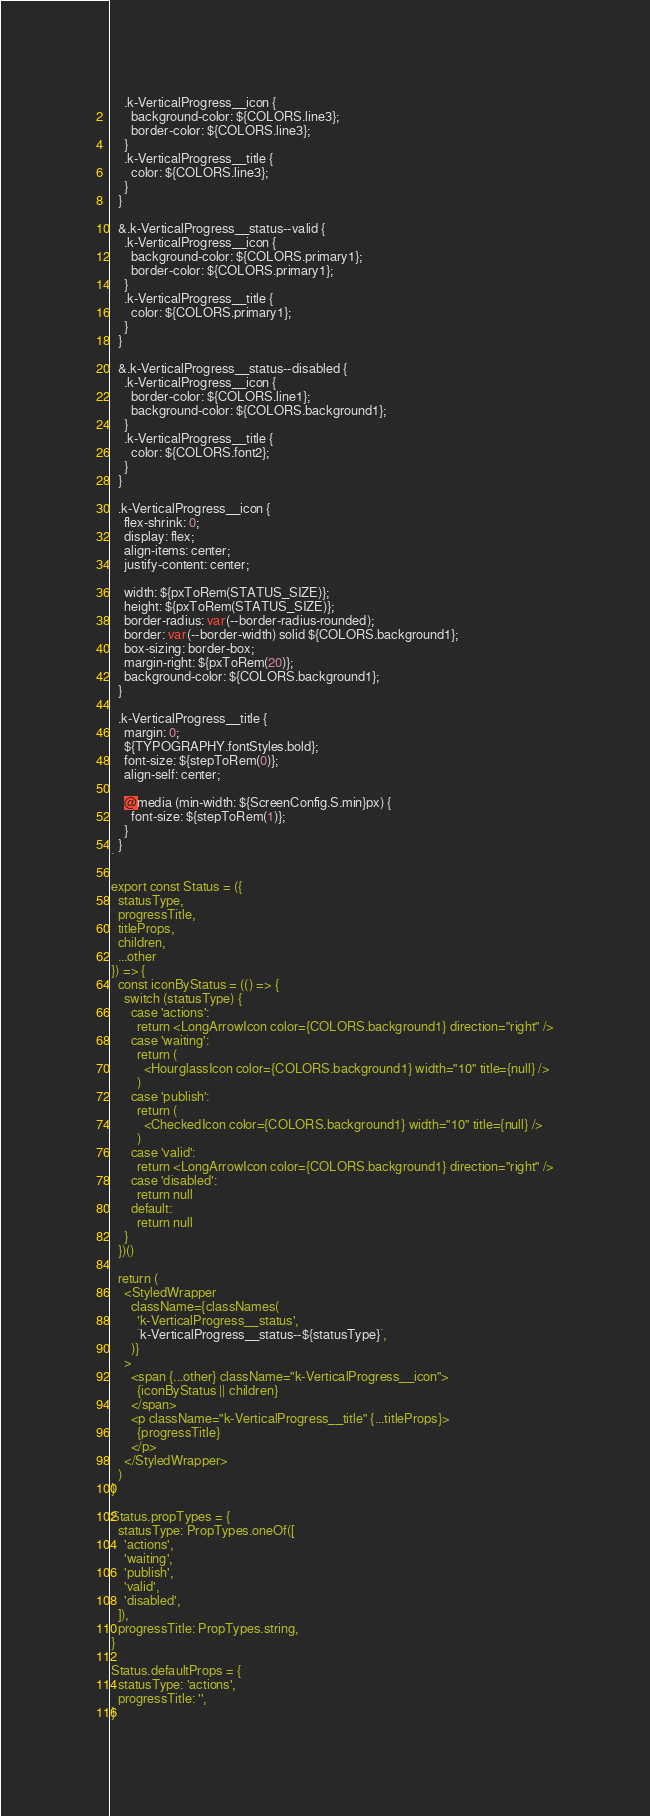<code> <loc_0><loc_0><loc_500><loc_500><_JavaScript_>    .k-VerticalProgress__icon {
      background-color: ${COLORS.line3};
      border-color: ${COLORS.line3};
    }
    .k-VerticalProgress__title {
      color: ${COLORS.line3};
    }
  }

  &.k-VerticalProgress__status--valid {
    .k-VerticalProgress__icon {
      background-color: ${COLORS.primary1};
      border-color: ${COLORS.primary1};
    }
    .k-VerticalProgress__title {
      color: ${COLORS.primary1};
    }
  }

  &.k-VerticalProgress__status--disabled {
    .k-VerticalProgress__icon {
      border-color: ${COLORS.line1};
      background-color: ${COLORS.background1};
    }
    .k-VerticalProgress__title {
      color: ${COLORS.font2};
    }
  }

  .k-VerticalProgress__icon {
    flex-shrink: 0;
    display: flex;
    align-items: center;
    justify-content: center;

    width: ${pxToRem(STATUS_SIZE)};
    height: ${pxToRem(STATUS_SIZE)};
    border-radius: var(--border-radius-rounded);
    border: var(--border-width) solid ${COLORS.background1};
    box-sizing: border-box;
    margin-right: ${pxToRem(20)};
    background-color: ${COLORS.background1};
  }

  .k-VerticalProgress__title {
    margin: 0;
    ${TYPOGRAPHY.fontStyles.bold};
    font-size: ${stepToRem(0)};
    align-self: center;

    @media (min-width: ${ScreenConfig.S.min}px) {
      font-size: ${stepToRem(1)};
    }
  }
`

export const Status = ({
  statusType,
  progressTitle,
  titleProps,
  children,
  ...other
}) => {
  const iconByStatus = (() => {
    switch (statusType) {
      case 'actions':
        return <LongArrowIcon color={COLORS.background1} direction="right" />
      case 'waiting':
        return (
          <HourglassIcon color={COLORS.background1} width="10" title={null} />
        )
      case 'publish':
        return (
          <CheckedIcon color={COLORS.background1} width="10" title={null} />
        )
      case 'valid':
        return <LongArrowIcon color={COLORS.background1} direction="right" />
      case 'disabled':
        return null
      default:
        return null
    }
  })()

  return (
    <StyledWrapper
      className={classNames(
        'k-VerticalProgress__status',
        `k-VerticalProgress__status--${statusType}`,
      )}
    >
      <span {...other} className="k-VerticalProgress__icon">
        {iconByStatus || children}
      </span>
      <p className="k-VerticalProgress__title" {...titleProps}>
        {progressTitle}
      </p>
    </StyledWrapper>
  )
}

Status.propTypes = {
  statusType: PropTypes.oneOf([
    'actions',
    'waiting',
    'publish',
    'valid',
    'disabled',
  ]),
  progressTitle: PropTypes.string,
}

Status.defaultProps = {
  statusType: 'actions',
  progressTitle: '',
}
</code> 